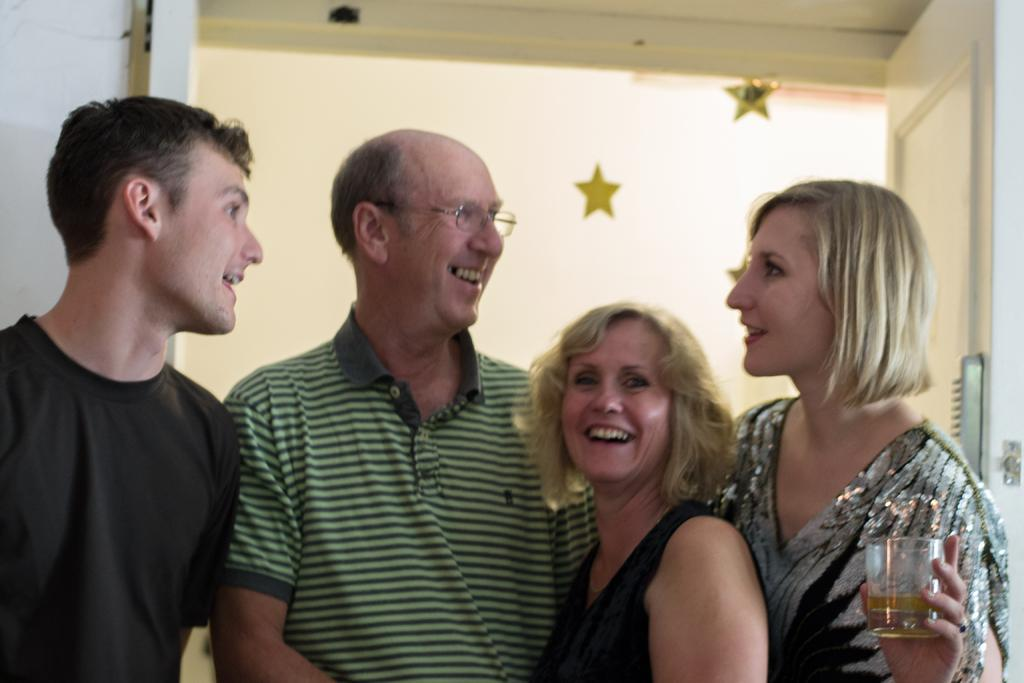How many people are in the image? There are four persons in the image. Can you describe the gender of the people in the image? Two of the persons are women, and two are men. What is one of the women holding in the image? One of the women is holding a glass of wine. What can be seen in the background of the image? There is a door and a wall in the background of the image. How many books are on the table in the image? There are no books visible in the image. What letters are being exchanged between the two men in the image? There is no indication of any letters being exchanged between the two men in the image. 